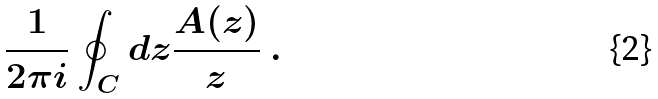Convert formula to latex. <formula><loc_0><loc_0><loc_500><loc_500>\frac { 1 } { 2 \pi i } \oint _ { C } d z \frac { A ( z ) } { z } \ .</formula> 